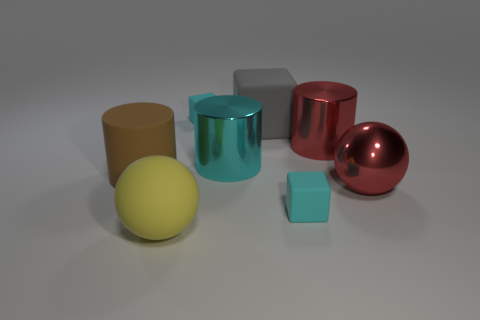Subtract all large matte cylinders. How many cylinders are left? 2 Add 1 big brown matte objects. How many objects exist? 9 Subtract all gray cubes. How many cubes are left? 2 Subtract all cubes. How many objects are left? 5 Subtract 2 blocks. How many blocks are left? 1 Subtract all tiny things. Subtract all cylinders. How many objects are left? 3 Add 3 small cyan rubber objects. How many small cyan rubber objects are left? 5 Add 7 tiny purple metal cylinders. How many tiny purple metal cylinders exist? 7 Subtract 0 yellow cubes. How many objects are left? 8 Subtract all blue balls. Subtract all blue blocks. How many balls are left? 2 